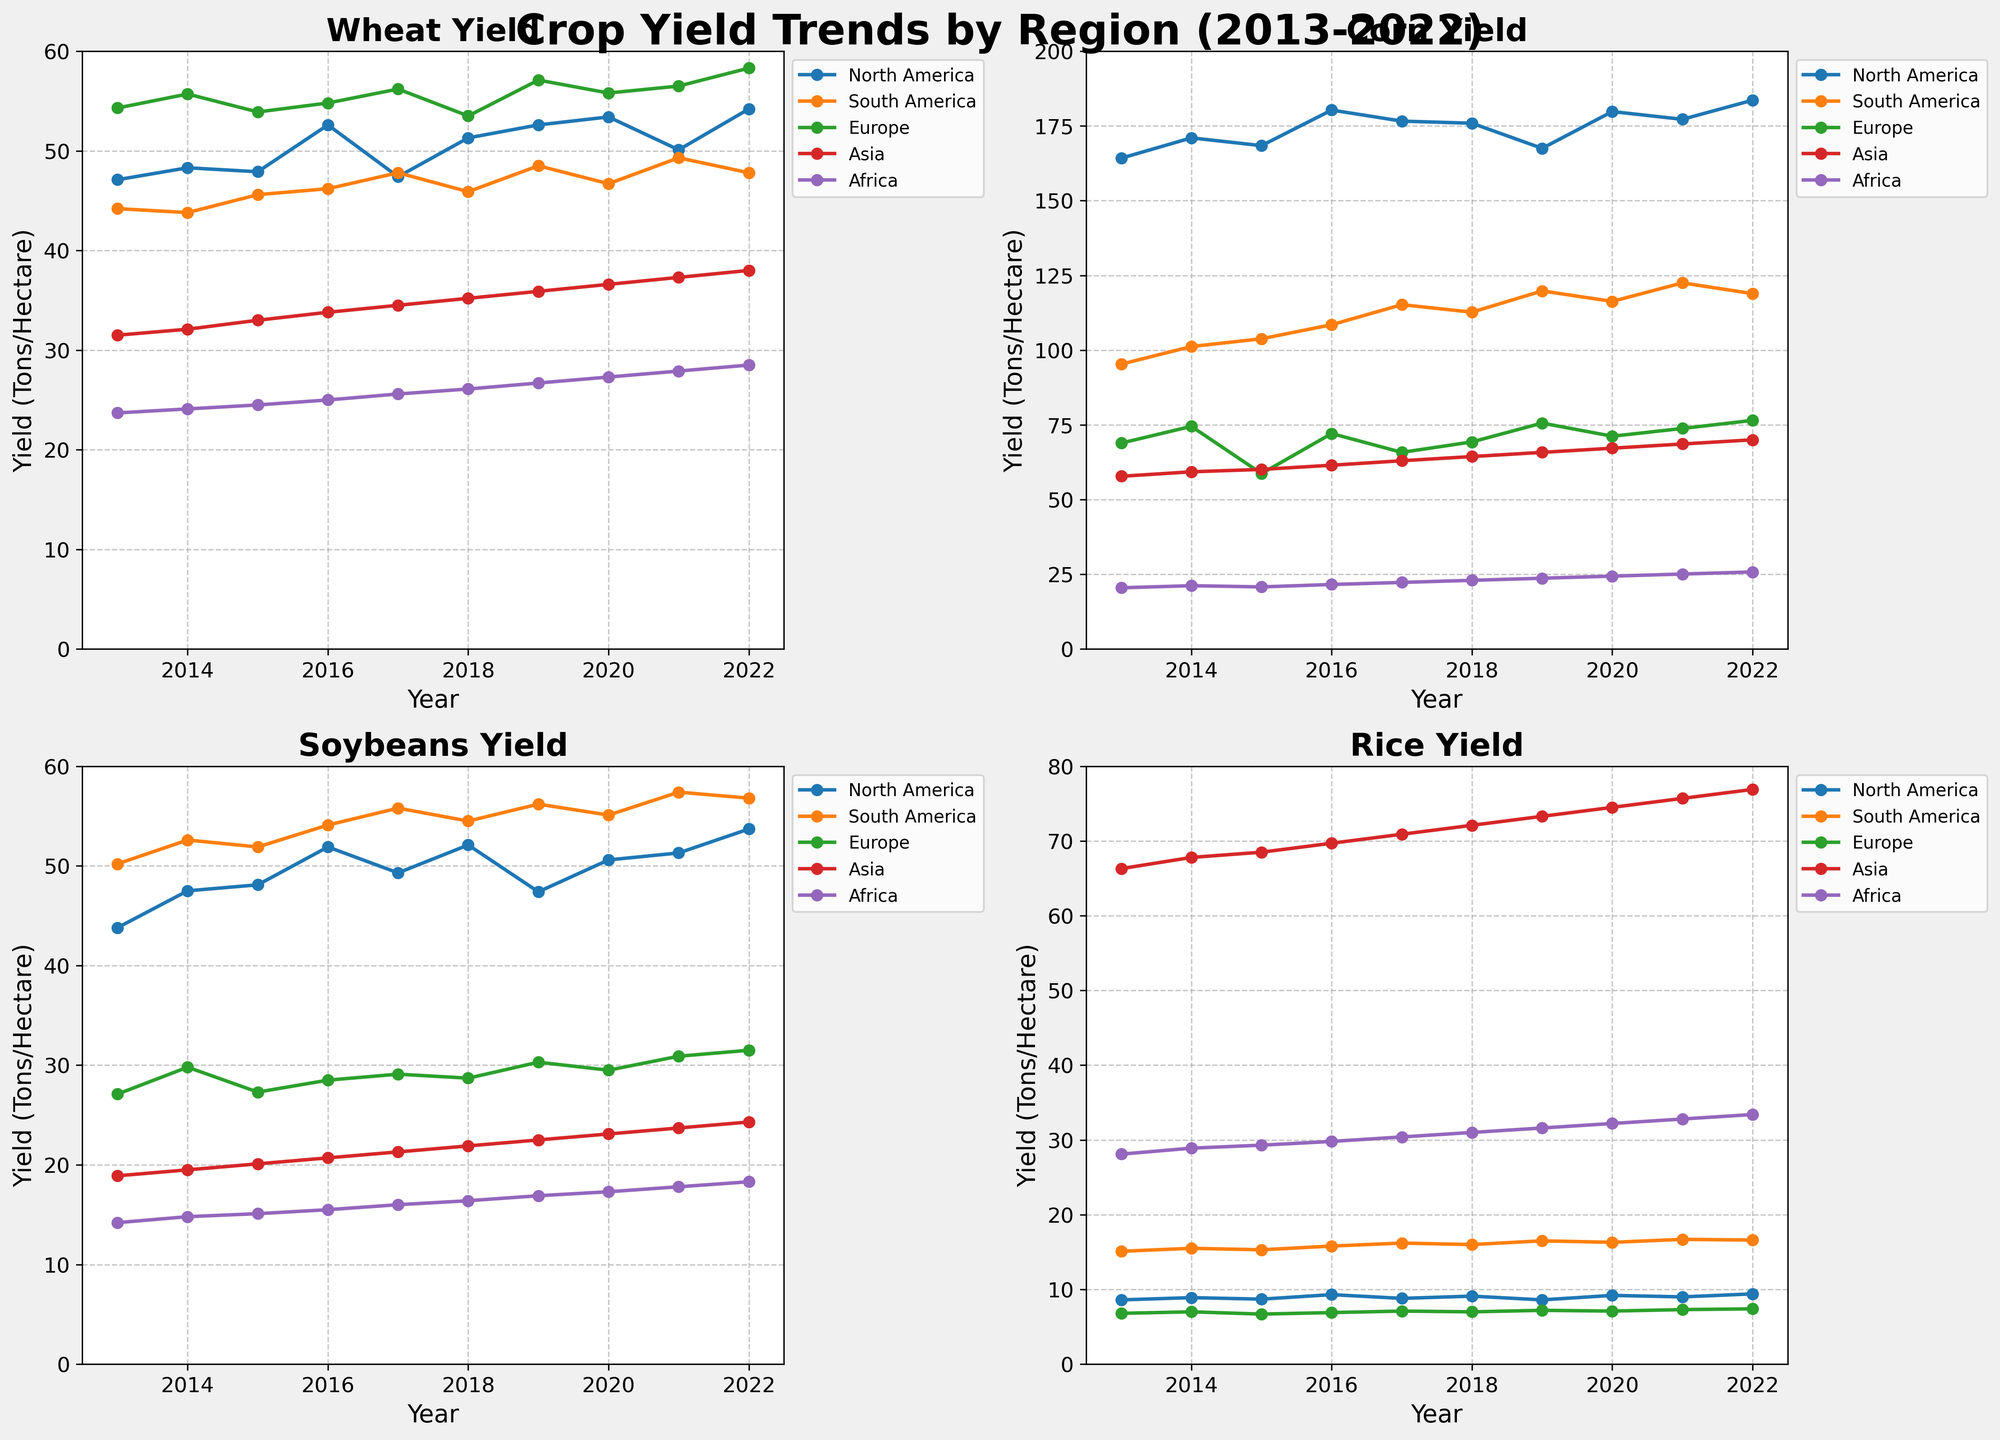What year had the highest wheat yield in Europe? Look at the subplot for wheat yield and find the line corresponding to Europe. Then, identify the highest point on that line and note the year.
Answer: 2022 Which region had the lowest corn yield in 2015? Examine the subplot for corn yield, locate the data points for 2015, and compare the heights of the data points for different regions. The smallest value indicates the region with the lowest yield.
Answer: Africa Compare the average soybean yield in North America and South America over the decade. Which one is higher? Calculate the average soybean yield for North America and South America by summing their yearly values from 2013 to 2022 and then dividing by 10. Compare these averages to determine which is higher.
Answer: South America How does the rice yield trend in Asia compare to other regions? In the rice yield subplot, compare the line for Asia with those of other regions. Notice the slope and general direction of the trend over the decade. Asia’s line should be consistently higher and upwards.
Answer: Higher and increasing By how much did the corn yield in North America increase from 2013 to 2022? Find the data points for North American corn yield in 2013 and 2022 on the corn yield subplot. Subtract the 2013 yield from the 2022 yield to find the increase.
Answer: 19.4 Which year did South America experience the highest soybean yield? Look at the subplot for soybean yield and find the line that represents South America. Identify the peak point on this line and note the year it corresponds to.
Answer: 2021 Compare the trends in wheat yield between North America and Europe. Do they display similar patterns? Observe the wheat yield subplot and compare the lines for North America and Europe. Note if the trends (increasing, decreasing, stable) are similar or if there are notable divergences.
Answer: Similar upward trend In which year did Africa have the maximum rice yield, and what was the yield? In the rice subplot, locate the highest point on the line for Africa and check the corresponding year and yield value.
Answer: 2022, 33.4 What is the overall trend in the corn yield for South America? Follow the line representing South America in the corn subplot from 2013 to 2022 and describe whether it is generally rising, falling, or stable.
Answer: Rising 